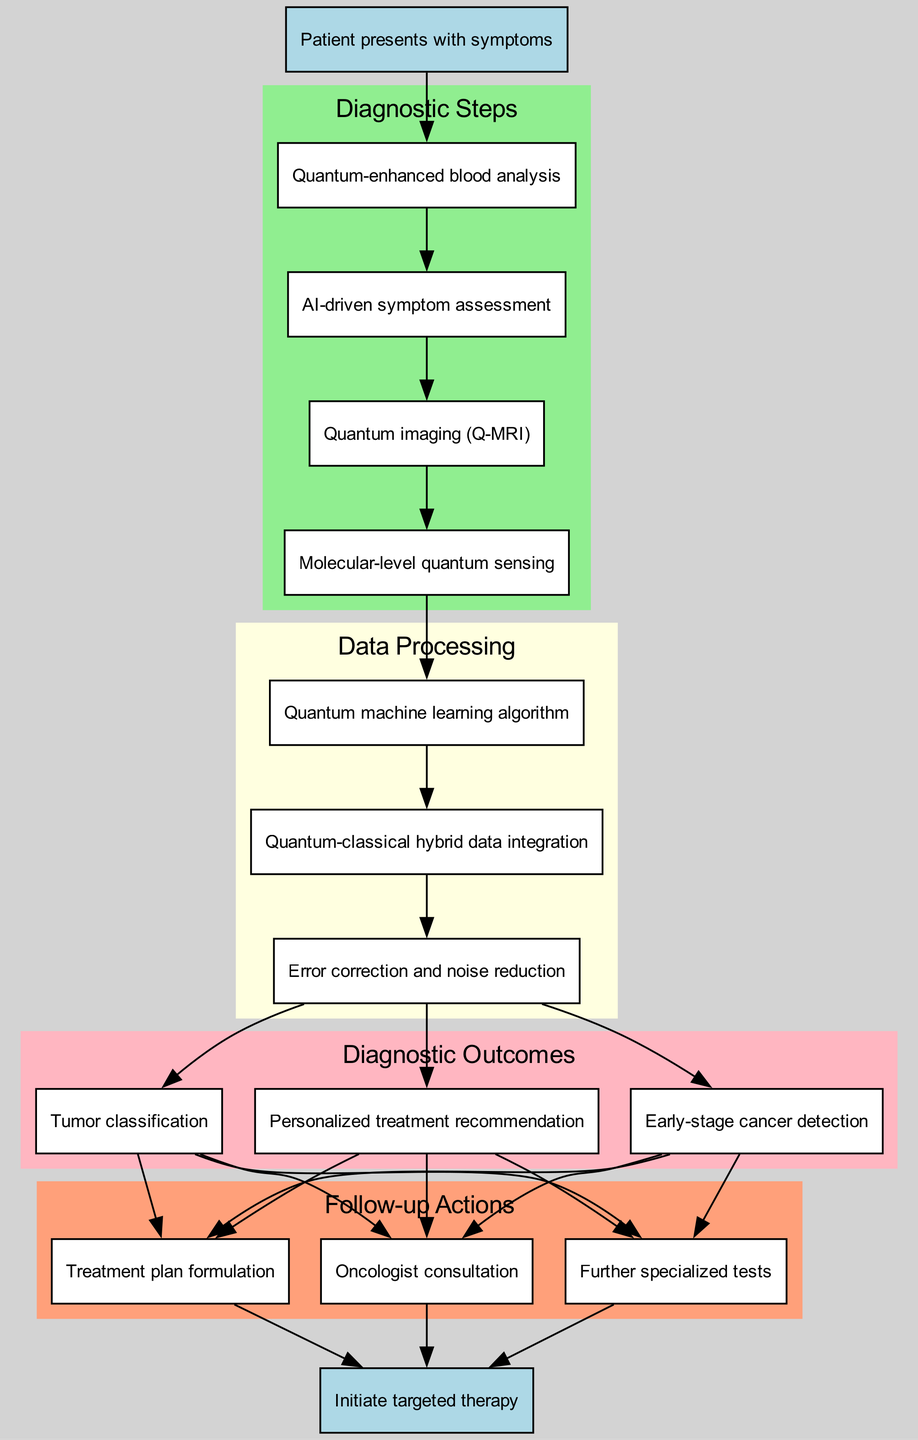What is the starting point of the diagnostic workflow? The starting point is specified at the top of the diagram as "Patient presents with symptoms." This is the initial node that begins the clinical pathway.
Answer: Patient presents with symptoms How many diagnostic steps are there in the pathway? The diagnostic steps are listed in a group, and by counting them, we find there are four steps: Quantum-enhanced blood analysis, AI-driven symptom assessment, Quantum imaging (Q-MRI), and Molecular-level quantum sensing.
Answer: 4 Which node follows "Quantum-enhanced blood analysis"? Following "Quantum-enhanced blood analysis," there is an edge connecting to "AI-driven symptom assessment." This represents the flow from one diagnostic step to the next in the pathway.
Answer: AI-driven symptom assessment What is the last action to be taken in the follow-up actions? The last action identified in the follow-up actions is "Treatment plan formulation." Reviewing the sequence of actions will show that it's the final step before reaching the endpoint of the workflow.
Answer: Treatment plan formulation What is the relationship between the last diagnostic outcome and the oncologist consultation? The last diagnostic outcome is "Personalized treatment recommendation." There are edges drawn from each diagnostic outcome to the follow-up actions, indicating a connection to "Oncologist consultation." Thus, the relationship is one of progression after determining the outcomes.
Answer: Connection How many follow-up actions are there in total? The follow-up actions group contains three distinct actions: Oncologist consultation, Further specialized tests, and Treatment plan formulation. By counting these actions, we assess the total number.
Answer: 3 Which data processing step directly follows the diagnostic steps? The first data processing step, "Quantum machine learning algorithm," directly follows the last diagnostic step, "Molecular-level quantum sensing." This transition marks a change in the type of process being conducted within the workflow.
Answer: Quantum machine learning algorithm What is the endpoint of the clinical pathway? The endpoint of the pathway is clearly indicated at the bottom of the diagram as "Initiate targeted therapy." It represents the ultimate goal of the diagnostic workflow after all preceding steps are completed.
Answer: Initiate targeted therapy What is the color of the nodes representing data processing? The nodes representing data processing steps are filled with light yellow color according to the subgraph's attributes defined in the diagram. This visual distinction helps to identify groupings in the workflow.
Answer: Light yellow 